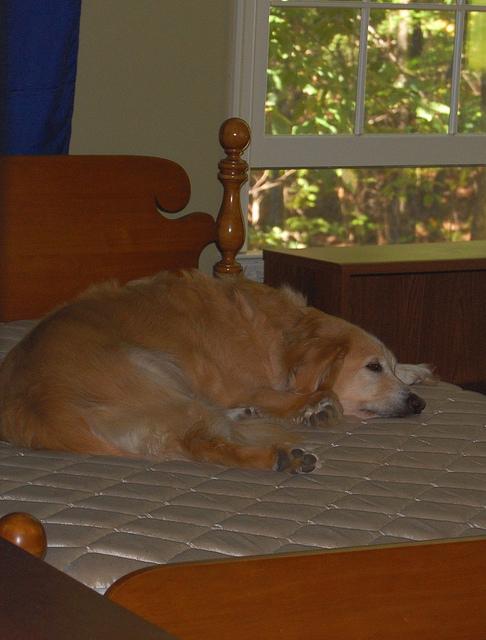Is the dog warming up in the sun?
Write a very short answer. No. Where is the dog sleeping?
Quick response, please. Bed. Is the dog happy?
Be succinct. Yes. Is the dog admiring himself?
Keep it brief. No. Could the dogs be hungry?
Answer briefly. No. Are the windows open?
Write a very short answer. Yes. Is the dog wearing a collar?
Keep it brief. No. Are there sheets on the bed?
Short answer required. No. What is the dog lying on?
Quick response, please. Bed. What is around the dog's neck?
Be succinct. Nothing. What kind of animal is this probably?
Write a very short answer. Dog. What is the dog doing?
Write a very short answer. Sleeping. How many dogs are there?
Answer briefly. 1. Is this scene happening inside or outside?
Keep it brief. Inside. 